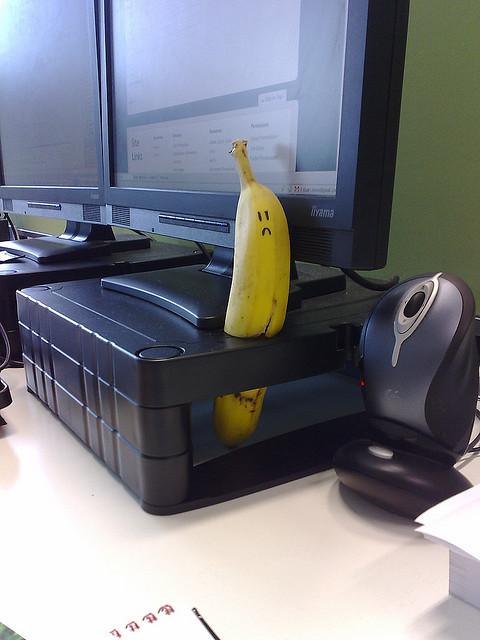Is the yellow object in the center of the picture an integral part of the computer?
Keep it brief. No. Does the computer have a mouse?
Concise answer only. Yes. Is the banana featuring human emotions?
Short answer required. Yes. 